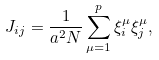Convert formula to latex. <formula><loc_0><loc_0><loc_500><loc_500>J _ { i j } = \frac { 1 } { a ^ { 2 } N } \sum _ { \mu = 1 } ^ { p } \xi _ { i } ^ { \mu } \xi _ { j } ^ { \mu } ,</formula> 